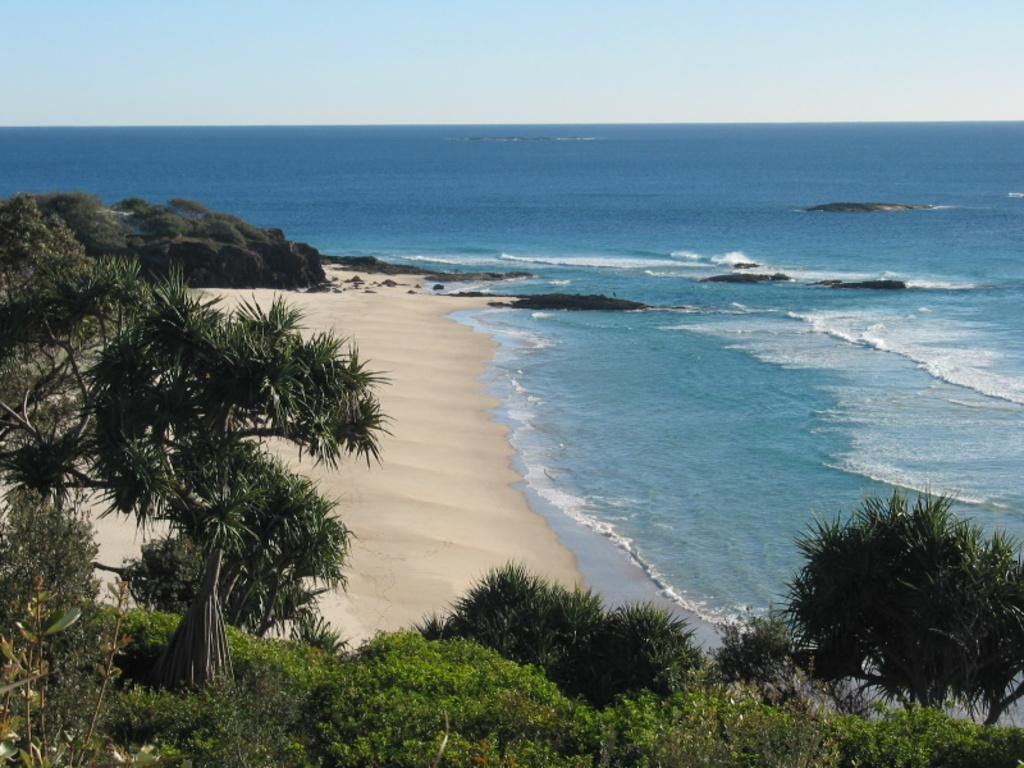What type of vegetation is in the foreground of the image? There are trees in the foreground of the image. What type of terrain is visible in the image? There is sand visible in the image. What natural feature is also visible in the image? There is water visible in the image. What can be seen in the sky in the image? There are clouds in the sky in the image. What color is the shirt worn by the person in the image? There is no person wearing a shirt in the image; it features trees, sand, water, and clouds. Where is the pan located in the image? There is no pan present in the image. 